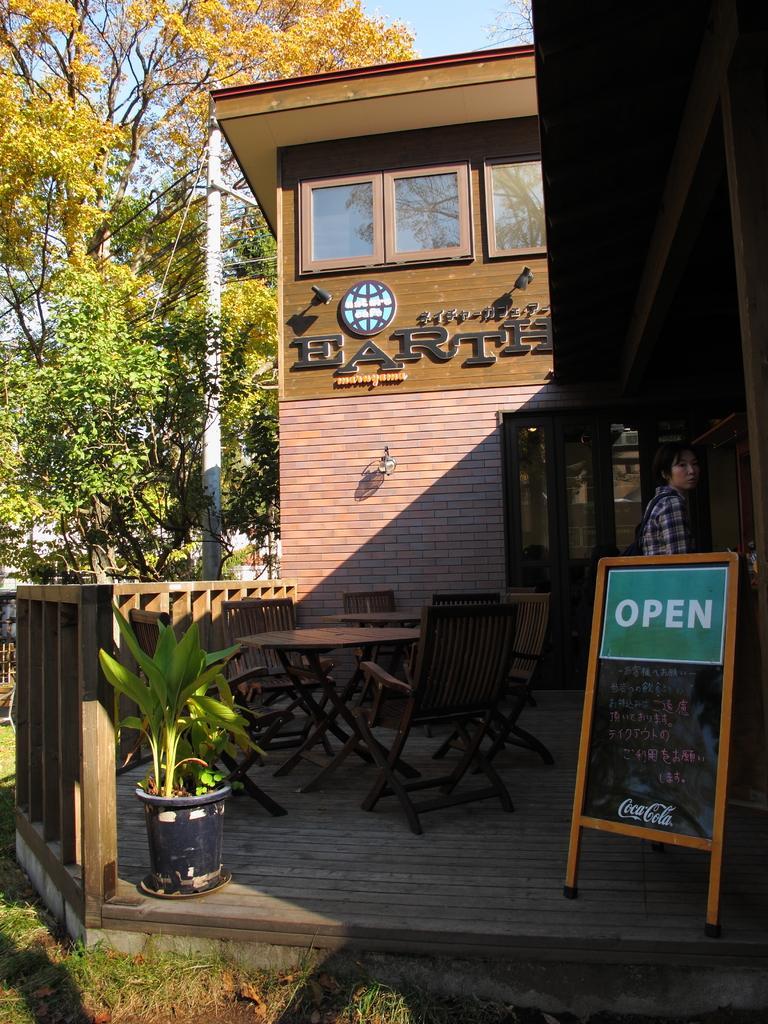In one or two sentences, can you explain what this image depicts? In the middle of the image there is a building and there are some chairs and tables. Bottom Right side of the image a man is standing. Bottom left side of the image there is a fencing and there is a plant. Top left side of the image there are some trees and pole. 